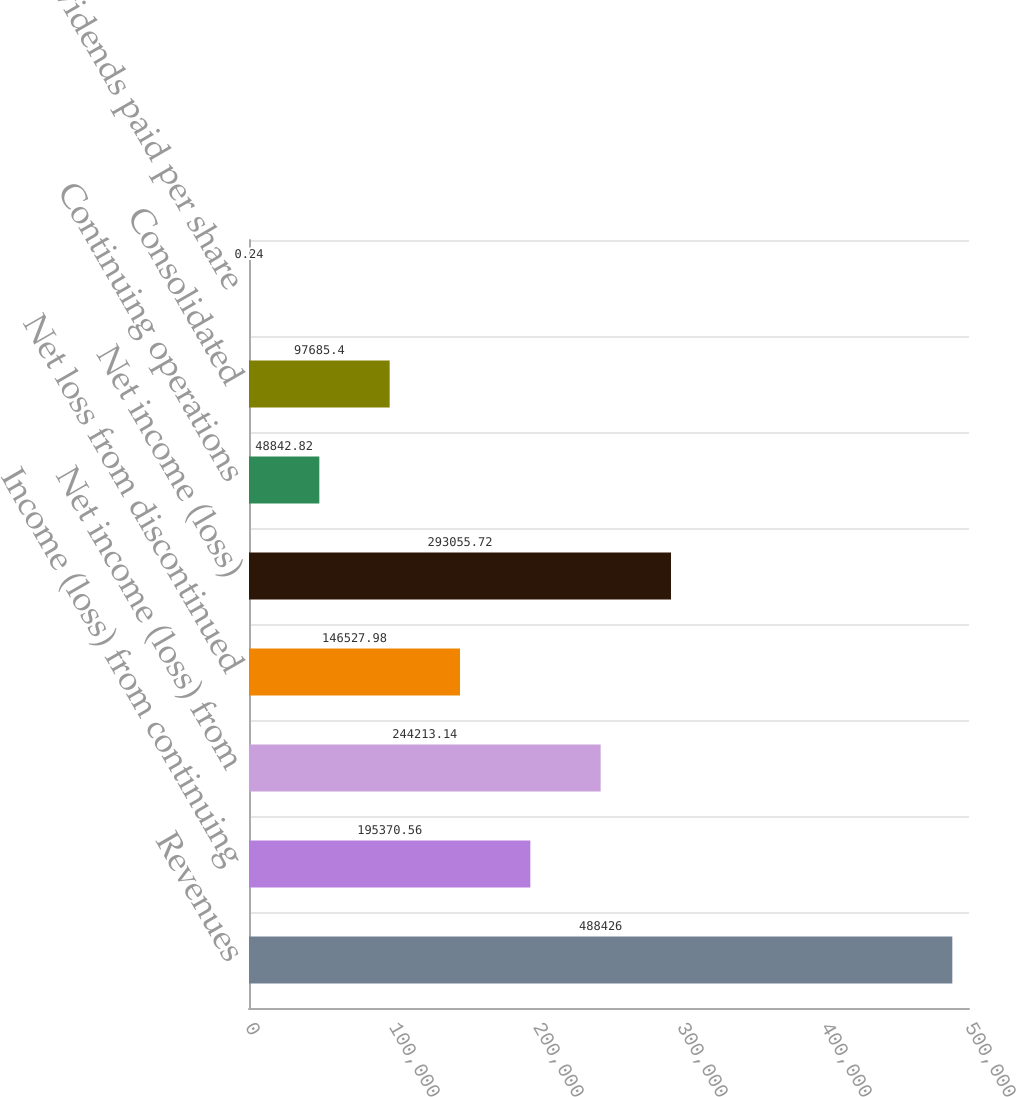<chart> <loc_0><loc_0><loc_500><loc_500><bar_chart><fcel>Revenues<fcel>Income (loss) from continuing<fcel>Net income (loss) from<fcel>Net loss from discontinued<fcel>Net income (loss)<fcel>Continuing operations<fcel>Consolidated<fcel>Dividends paid per share<nl><fcel>488426<fcel>195371<fcel>244213<fcel>146528<fcel>293056<fcel>48842.8<fcel>97685.4<fcel>0.24<nl></chart> 